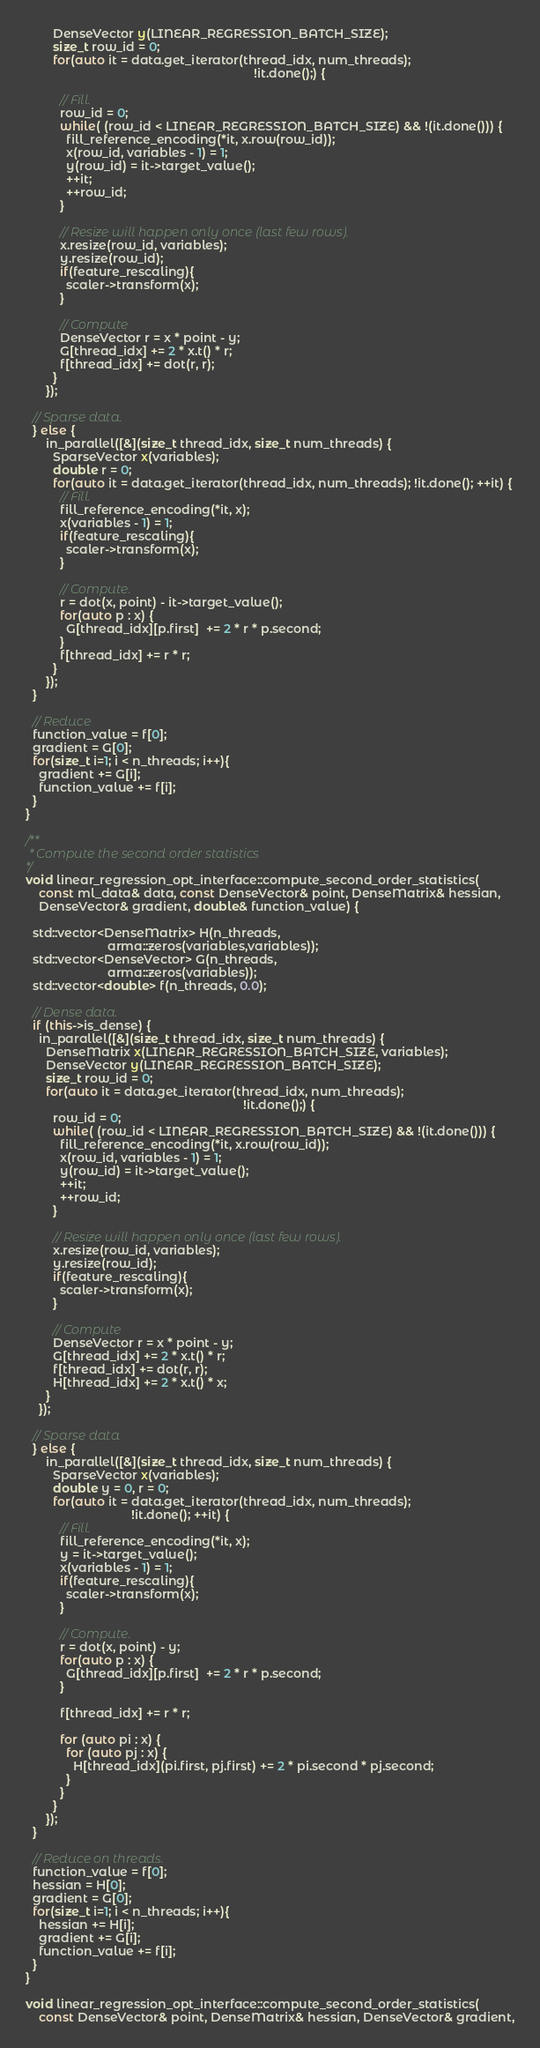<code> <loc_0><loc_0><loc_500><loc_500><_C++_>        DenseVector y(LINEAR_REGRESSION_BATCH_SIZE);
        size_t row_id = 0;
        for(auto it = data.get_iterator(thread_idx, num_threads);
                                                                   !it.done();) {

          // Fill.
          row_id = 0;
          while( (row_id < LINEAR_REGRESSION_BATCH_SIZE) && !(it.done())) {
            fill_reference_encoding(*it, x.row(row_id));
            x(row_id, variables - 1) = 1;
            y(row_id) = it->target_value();
            ++it;
            ++row_id;
          }

          // Resize will happen only once (last few rows).
          x.resize(row_id, variables);
          y.resize(row_id);
          if(feature_rescaling){
            scaler->transform(x);
          }
          
          // Compute
          DenseVector r = x * point - y;
          G[thread_idx] += 2 * x.t() * r;
          f[thread_idx] += dot(r, r);
        }
      });

  // Sparse data.
  } else {
      in_parallel([&](size_t thread_idx, size_t num_threads) {
        SparseVector x(variables);
        double r = 0;
        for(auto it = data.get_iterator(thread_idx, num_threads); !it.done(); ++it) {
          // Fill.
          fill_reference_encoding(*it, x);
          x(variables - 1) = 1;
          if(feature_rescaling){
            scaler->transform(x);
          }

          // Compute.
          r = dot(x, point) - it->target_value();
          for(auto p : x) {
            G[thread_idx][p.first]  += 2 * r * p.second;
          }
          f[thread_idx] += r * r;
        }
      });
  }

  // Reduce
  function_value = f[0];
  gradient = G[0];
  for(size_t i=1; i < n_threads; i++){
    gradient += G[i];
    function_value += f[i];
  }
}

/**
 * Compute the second order statistics
*/
void linear_regression_opt_interface::compute_second_order_statistics(
    const ml_data& data, const DenseVector& point, DenseMatrix& hessian,
    DenseVector& gradient, double& function_value) {

  std::vector<DenseMatrix> H(n_threads, 
                        arma::zeros(variables,variables));
  std::vector<DenseVector> G(n_threads, 
                        arma::zeros(variables));
  std::vector<double> f(n_threads, 0.0);
  
  // Dense data. 
  if (this->is_dense) {
    in_parallel([&](size_t thread_idx, size_t num_threads) {
      DenseMatrix x(LINEAR_REGRESSION_BATCH_SIZE, variables);
      DenseVector y(LINEAR_REGRESSION_BATCH_SIZE);
      size_t row_id = 0;
      for(auto it = data.get_iterator(thread_idx, num_threads); 
                                                                !it.done();) {
        row_id = 0;
        while( (row_id < LINEAR_REGRESSION_BATCH_SIZE) && !(it.done())) {
          fill_reference_encoding(*it, x.row(row_id));
          x(row_id, variables - 1) = 1;
          y(row_id) = it->target_value();
          ++it;
          ++row_id;
        }

        // Resize will happen only once (last few rows).
        x.resize(row_id, variables);
        y.resize(row_id);
        if(feature_rescaling){
          scaler->transform(x);
        }

        // Compute
        DenseVector r = x * point - y;
        G[thread_idx] += 2 * x.t() * r;
        f[thread_idx] += dot(r, r);
        H[thread_idx] += 2 * x.t() * x;
      }
    });

  // Sparse data
  } else {
      in_parallel([&](size_t thread_idx, size_t num_threads) {
        SparseVector x(variables);
        double y = 0, r = 0;
        for(auto it = data.get_iterator(thread_idx, num_threads); 
                               !it.done(); ++it) {
          // Fill.
          fill_reference_encoding(*it, x);
          y = it->target_value();
          x(variables - 1) = 1;
          if(feature_rescaling){
            scaler->transform(x);
          }
                            
          // Compute.       
          r = dot(x, point) - y;
          for(auto p : x) {
            G[thread_idx][p.first]  += 2 * r * p.second;
          }

          f[thread_idx] += r * r;

          for (auto pi : x) {
            for (auto pj : x) {
              H[thread_idx](pi.first, pj.first) += 2 * pi.second * pj.second;
            }
          }
        }
      });
  }

  // Reduce on threads.
  function_value = f[0];
  hessian = H[0];
  gradient = G[0];
  for(size_t i=1; i < n_threads; i++){
    hessian += H[i];
    gradient += G[i];
    function_value += f[i];
  }
}

void linear_regression_opt_interface::compute_second_order_statistics(
    const DenseVector& point, DenseMatrix& hessian, DenseVector& gradient,</code> 